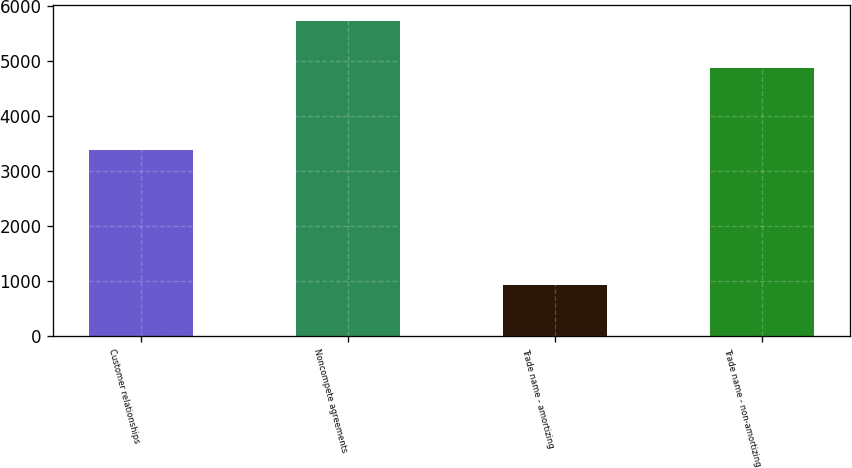Convert chart. <chart><loc_0><loc_0><loc_500><loc_500><bar_chart><fcel>Customer relationships<fcel>Noncompete agreements<fcel>Trade name - amortizing<fcel>Trade name - non-amortizing<nl><fcel>3377<fcel>5724<fcel>926<fcel>4868<nl></chart> 